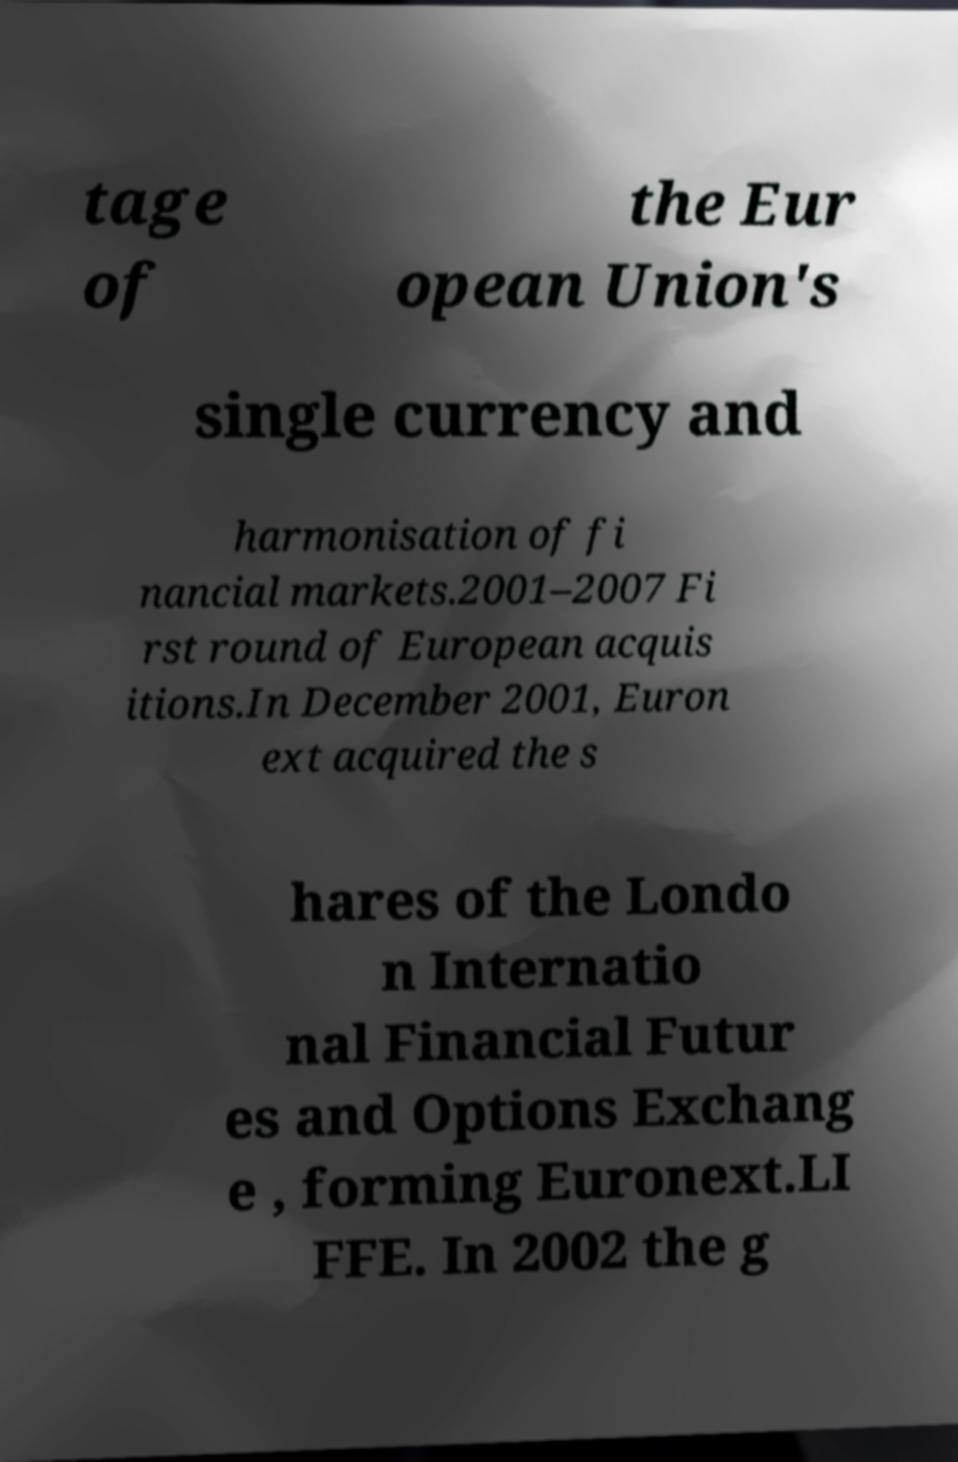Could you assist in decoding the text presented in this image and type it out clearly? tage of the Eur opean Union's single currency and harmonisation of fi nancial markets.2001–2007 Fi rst round of European acquis itions.In December 2001, Euron ext acquired the s hares of the Londo n Internatio nal Financial Futur es and Options Exchang e , forming Euronext.LI FFE. In 2002 the g 